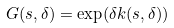<formula> <loc_0><loc_0><loc_500><loc_500>G ( s , \delta ) = \exp ( \delta k ( s , \delta ) )</formula> 